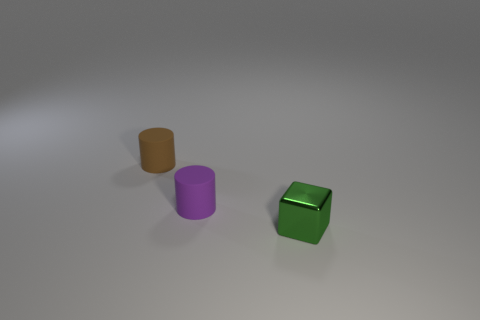Could you describe the lighting used in this scene? The lighting in the scene appears to be diffused, casting soft shadows beneath the objects. It likely comes from a source above, creating reflections on the tops of the shapes, emphasizing their glossiness. 